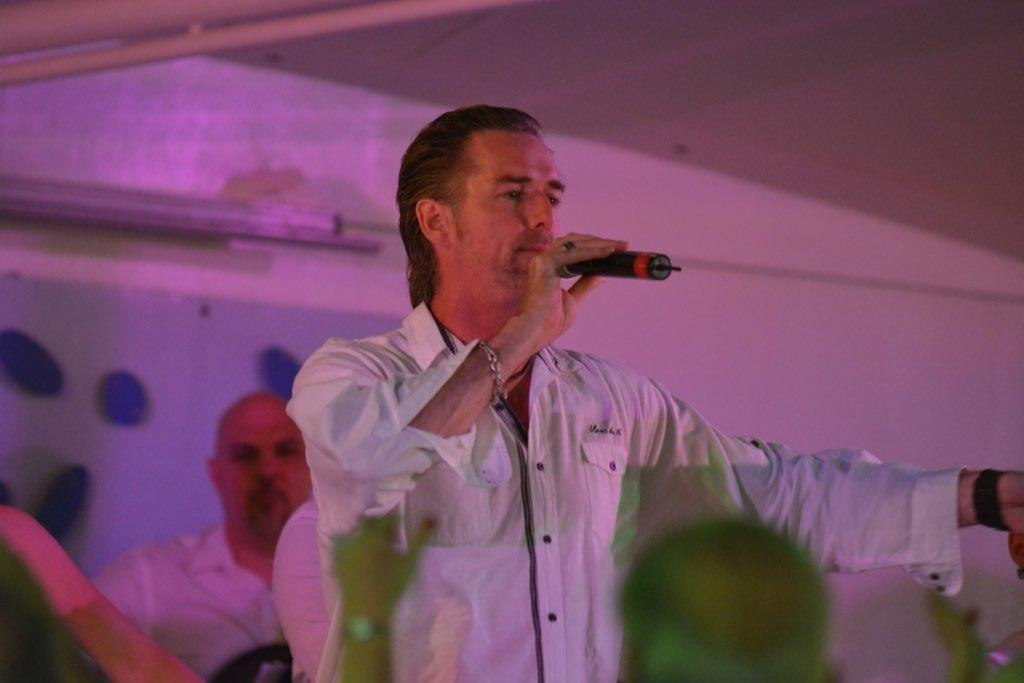What is the person in the image holding? The person is holding a mic in the image. Can you describe any accessories the person is wearing? The person is wearing a watch and a bracelet. What can be seen in the background of the image? There is another person and a wall in the background of the image. What is the weather like in the image? The provided facts do not mention any information about the weather, so it cannot be determined from the image. 